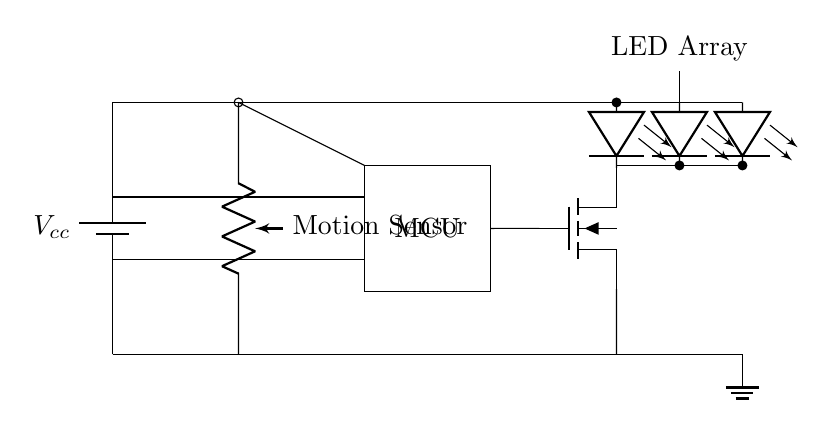what is the type of sensor used in this circuit? The circuit employs a motion sensor, indicated by the label next to the symbol in the diagram. The symbol refers to a passive component that detects movement.
Answer: motion sensor what components are used to activate the LED array? The LED array is activated by a MOSFET, which is connected to the microcontroller and controlled by the motion sensor. The microcontroller processes the input signal from the sensor to control the MOSFET, thus turning on the LED array.
Answer: MOSFET and microcontroller how many LEDs are shown in the circuit? The circuit diagram illustrates three individual LED components, all connected in parallel to form the LED array. Each LED is shown with its own symbol in the diagram.
Answer: three what is the function of the microcontroller in this circuit? The microcontroller processes the input signal from the motion sensor and determines whether to turn the LED array on or off based on detected motion. It acts as the decision-making unit that controls the MOSFET based on logic programmed into it.
Answer: control the LED array describe the power supply voltage in the circuit. The power supply voltage is represented as Vcc in the circuit diagram. This indicates the voltage provided to the circuit, which is typically a standard voltage like 5V or 12V, though the exact value isn't specified in the diagram.
Answer: Vcc how does the motion sensor influence the power consumption of the circuit? The motion sensor reduces power consumption by only activating the LED array when motion is detected, avoiding constant use. When there is no motion, the sensor keeps the LED array off, thereby conserving energy. This is a key feature of energy-efficient designs.
Answer: reduces power consumption what role does the ground play in this circuit? The ground serves as a reference point for the voltage in the circuit and provides a return path for the current. It ensures that the voltage levels are stable and allows the components in the circuit to function correctly, effectively closing the circuit loop.
Answer: reference point and return path 